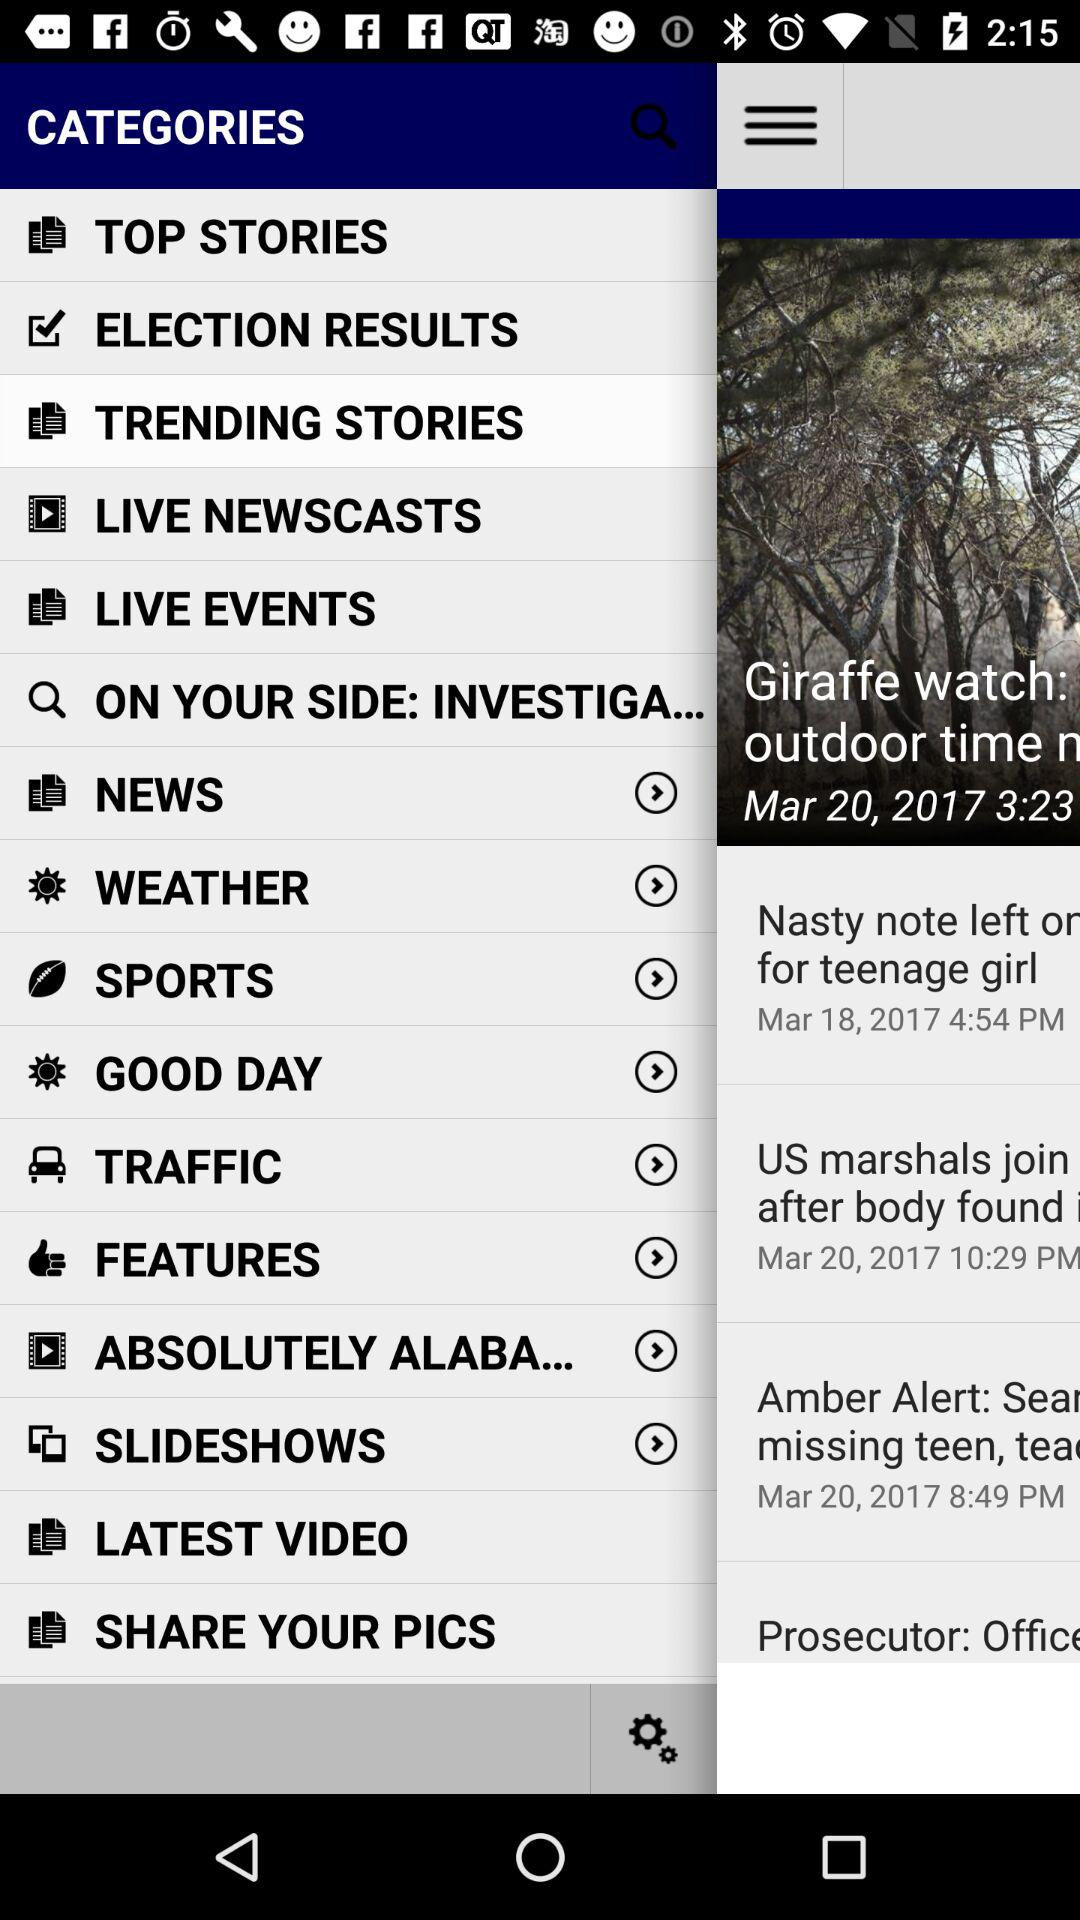Which item is selected? The selected item is "TRENDING STORIES". 